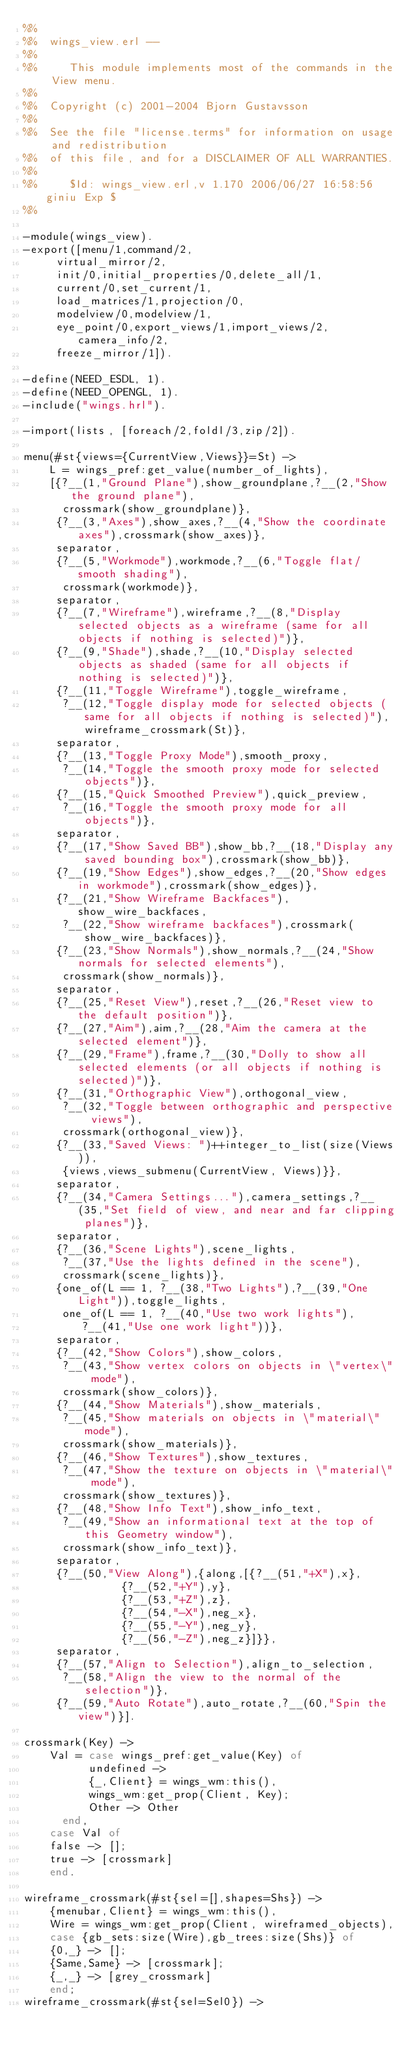Convert code to text. <code><loc_0><loc_0><loc_500><loc_500><_Erlang_>%%
%%  wings_view.erl --
%%
%%     This module implements most of the commands in the View menu.
%%
%%  Copyright (c) 2001-2004 Bjorn Gustavsson
%%
%%  See the file "license.terms" for information on usage and redistribution
%%  of this file, and for a DISCLAIMER OF ALL WARRANTIES.
%%
%%     $Id: wings_view.erl,v 1.170 2006/06/27 16:58:56 giniu Exp $
%%

-module(wings_view).
-export([menu/1,command/2,
	 virtual_mirror/2,
	 init/0,initial_properties/0,delete_all/1,
	 current/0,set_current/1,
	 load_matrices/1,projection/0,
	 modelview/0,modelview/1,
	 eye_point/0,export_views/1,import_views/2,camera_info/2,
	 freeze_mirror/1]).

-define(NEED_ESDL, 1).
-define(NEED_OPENGL, 1).
-include("wings.hrl").

-import(lists, [foreach/2,foldl/3,zip/2]).

menu(#st{views={CurrentView,Views}}=St) ->
    L = wings_pref:get_value(number_of_lights),
    [{?__(1,"Ground Plane"),show_groundplane,?__(2,"Show the ground plane"),
      crossmark(show_groundplane)},
     {?__(3,"Axes"),show_axes,?__(4,"Show the coordinate axes"),crossmark(show_axes)},
     separator,
     {?__(5,"Workmode"),workmode,?__(6,"Toggle flat/smooth shading"),
      crossmark(workmode)},
     separator,
     {?__(7,"Wireframe"),wireframe,?__(8,"Display selected objects as a wireframe (same for all objects if nothing is selected)")},
     {?__(9,"Shade"),shade,?__(10,"Display selected objects as shaded (same for all objects if nothing is selected)")},
     {?__(11,"Toggle Wireframe"),toggle_wireframe,
      ?__(12,"Toggle display mode for selected objects (same for all objects if nothing is selected)"),wireframe_crossmark(St)},
     separator,
     {?__(13,"Toggle Proxy Mode"),smooth_proxy,
      ?__(14,"Toggle the smooth proxy mode for selected objects")},
     {?__(15,"Quick Smoothed Preview"),quick_preview,
      ?__(16,"Toggle the smooth proxy mode for all objects")},
     separator,
     {?__(17,"Show Saved BB"),show_bb,?__(18,"Display any saved bounding box"),crossmark(show_bb)},
     {?__(19,"Show Edges"),show_edges,?__(20,"Show edges in workmode"),crossmark(show_edges)},
     {?__(21,"Show Wireframe Backfaces"),show_wire_backfaces,
      ?__(22,"Show wireframe backfaces"),crossmark(show_wire_backfaces)},
     {?__(23,"Show Normals"),show_normals,?__(24,"Show normals for selected elements"),
      crossmark(show_normals)},
     separator,
     {?__(25,"Reset View"),reset,?__(26,"Reset view to the default position")},
     {?__(27,"Aim"),aim,?__(28,"Aim the camera at the selected element")},
     {?__(29,"Frame"),frame,?__(30,"Dolly to show all selected elements (or all objects if nothing is selected)")},
     {?__(31,"Orthographic View"),orthogonal_view,
      ?__(32,"Toggle between orthographic and perspective views"),
      crossmark(orthogonal_view)},
     {?__(33,"Saved Views: ")++integer_to_list(size(Views)),
      {views,views_submenu(CurrentView, Views)}},
     separator,
     {?__(34,"Camera Settings..."),camera_settings,?__(35,"Set field of view, and near and far clipping planes")},
     separator,
     {?__(36,"Scene Lights"),scene_lights,
      ?__(37,"Use the lights defined in the scene"),
      crossmark(scene_lights)},
     {one_of(L == 1, ?__(38,"Two Lights"),?__(39,"One Light")),toggle_lights,
      one_of(L == 1, ?__(40,"Use two work lights"),
	     ?__(41,"Use one work light"))},
     separator,
     {?__(42,"Show Colors"),show_colors,
      ?__(43,"Show vertex colors on objects in \"vertex\" mode"),
      crossmark(show_colors)},
     {?__(44,"Show Materials"),show_materials,
      ?__(45,"Show materials on objects in \"material\" mode"),
      crossmark(show_materials)},
     {?__(46,"Show Textures"),show_textures,
      ?__(47,"Show the texture on objects in \"material\" mode"),
      crossmark(show_textures)},
     {?__(48,"Show Info Text"),show_info_text,
      ?__(49,"Show an informational text at the top of this Geometry window"),
      crossmark(show_info_text)},
     separator,
     {?__(50,"View Along"),{along,[{?__(51,"+X"),x},
			   {?__(52,"+Y"),y},
			   {?__(53,"+Z"),z},
			   {?__(54,"-X"),neg_x},
			   {?__(55,"-Y"),neg_y},
			   {?__(56,"-Z"),neg_z}]}},
     separator,
     {?__(57,"Align to Selection"),align_to_selection,
      ?__(58,"Align the view to the normal of the selection")},
     {?__(59,"Auto Rotate"),auto_rotate,?__(60,"Spin the view")}].

crossmark(Key) ->
    Val = case wings_pref:get_value(Key) of
	      undefined ->
		  {_,Client} = wings_wm:this(),
		  wings_wm:get_prop(Client, Key);
	      Other -> Other
	  end,
    case Val of
	false -> [];
	true -> [crossmark]
    end.

wireframe_crossmark(#st{sel=[],shapes=Shs}) ->
    {menubar,Client} = wings_wm:this(),
    Wire = wings_wm:get_prop(Client, wireframed_objects),
    case {gb_sets:size(Wire),gb_trees:size(Shs)} of
	{0,_} -> [];
	{Same,Same} -> [crossmark];
	{_,_} -> [grey_crossmark]
    end;
wireframe_crossmark(#st{sel=Sel0}) -></code> 